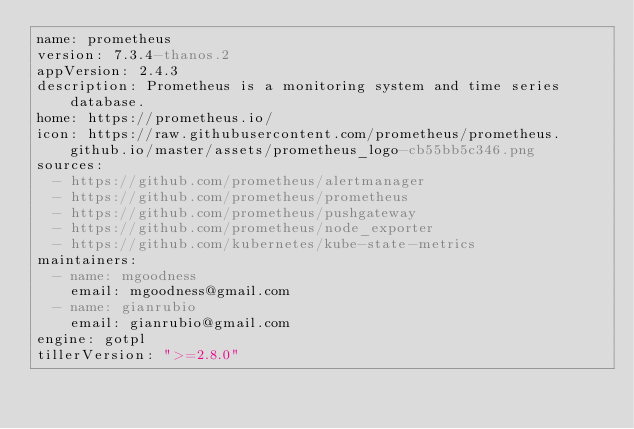Convert code to text. <code><loc_0><loc_0><loc_500><loc_500><_YAML_>name: prometheus
version: 7.3.4-thanos.2
appVersion: 2.4.3
description: Prometheus is a monitoring system and time series database.
home: https://prometheus.io/
icon: https://raw.githubusercontent.com/prometheus/prometheus.github.io/master/assets/prometheus_logo-cb55bb5c346.png
sources:
  - https://github.com/prometheus/alertmanager
  - https://github.com/prometheus/prometheus
  - https://github.com/prometheus/pushgateway
  - https://github.com/prometheus/node_exporter
  - https://github.com/kubernetes/kube-state-metrics
maintainers:
  - name: mgoodness
    email: mgoodness@gmail.com
  - name: gianrubio
    email: gianrubio@gmail.com
engine: gotpl
tillerVersion: ">=2.8.0"
</code> 